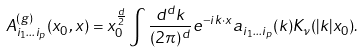<formula> <loc_0><loc_0><loc_500><loc_500>A _ { i _ { 1 } \dots i _ { p } } ^ { ( g ) } ( x _ { 0 } , { x } ) = x _ { 0 } ^ { \frac { d } { 2 } } \int { \frac { d ^ { d } k } { ( 2 \pi ) ^ { d } } } e ^ { - i { k } \cdot { x } } a _ { i _ { 1 } \dots i _ { p } } ( { k } ) K _ { \nu } ( | { k } | x _ { 0 } ) .</formula> 